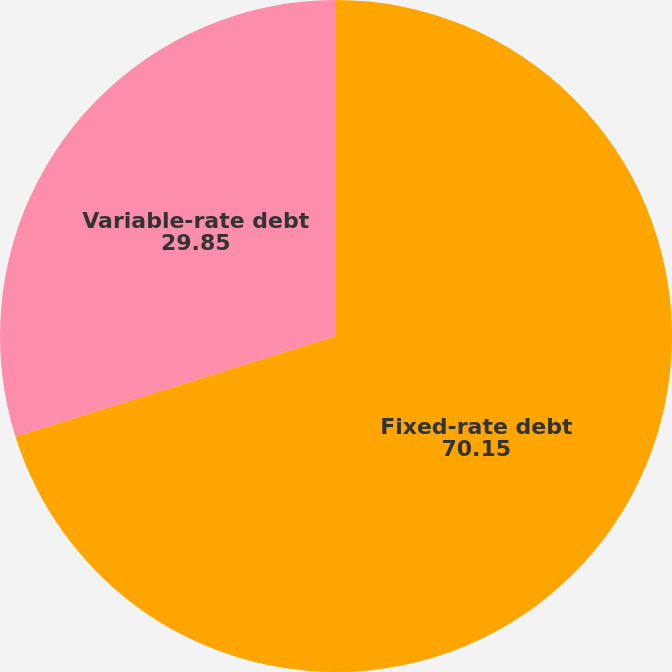Convert chart to OTSL. <chart><loc_0><loc_0><loc_500><loc_500><pie_chart><fcel>Fixed-rate debt<fcel>Variable-rate debt<nl><fcel>70.15%<fcel>29.85%<nl></chart> 